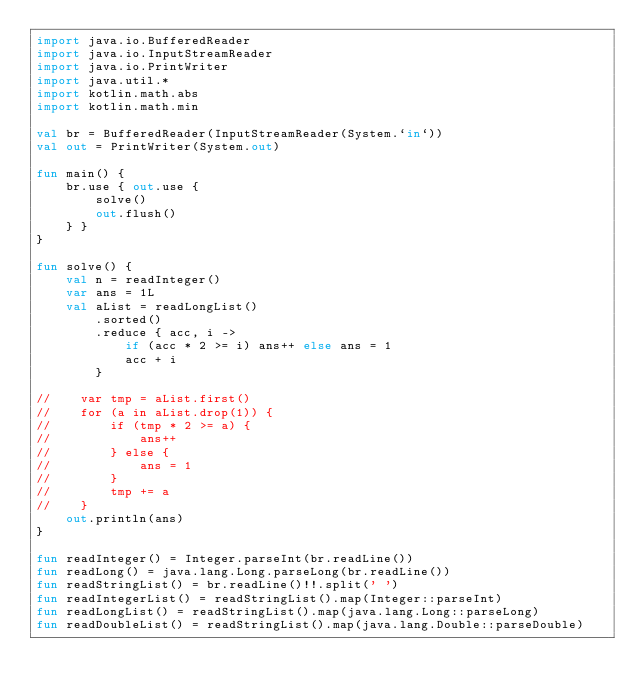<code> <loc_0><loc_0><loc_500><loc_500><_Kotlin_>import java.io.BufferedReader
import java.io.InputStreamReader
import java.io.PrintWriter
import java.util.*
import kotlin.math.abs
import kotlin.math.min

val br = BufferedReader(InputStreamReader(System.`in`))
val out = PrintWriter(System.out)

fun main() {
    br.use { out.use {
        solve()
        out.flush()
    } }
}

fun solve() {
    val n = readInteger()
    var ans = 1L
    val aList = readLongList()
        .sorted()
        .reduce { acc, i ->
            if (acc * 2 >= i) ans++ else ans = 1
            acc + i
        }

//    var tmp = aList.first()
//    for (a in aList.drop(1)) {
//        if (tmp * 2 >= a) {
//            ans++
//        } else {
//            ans = 1
//        }
//        tmp += a
//    }
    out.println(ans)
}

fun readInteger() = Integer.parseInt(br.readLine())
fun readLong() = java.lang.Long.parseLong(br.readLine())
fun readStringList() = br.readLine()!!.split(' ')
fun readIntegerList() = readStringList().map(Integer::parseInt)
fun readLongList() = readStringList().map(java.lang.Long::parseLong)
fun readDoubleList() = readStringList().map(java.lang.Double::parseDouble)
</code> 